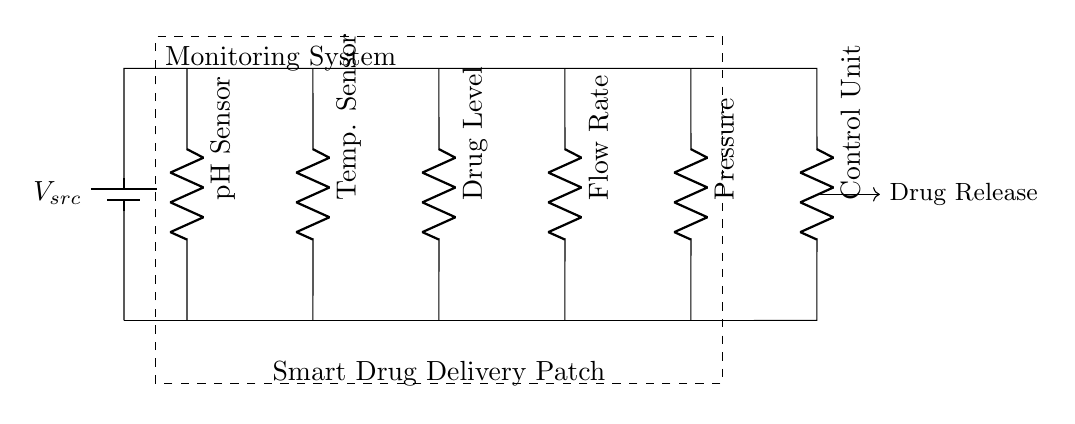What type of sensors are used in the smart drug delivery patch? The circuit diagram indicates five types of sensors: pH Sensor, Temperature Sensor, Drug Level, Flow Rate, and Pressure. These are positioned vertically in parallel, indicating they monitor different parameters simultaneously.
Answer: pH Sensor, Temperature Sensor, Drug Level, Flow Rate, Pressure What is the function of the control unit in this circuit? The control unit is downstream of the sensors and is responsible for processing the data collected from them. It likely regulates the drug release based on this information, which is indicated by the arrow leading to 'Drug Release.'
Answer: Regulate drug release How many resistors are depicted in the circuit? Each sensor is represented as a resistor in the circuit diagram. There are five sensors, therefore there are five resistors present.
Answer: Five What component is connected to all sensors in parallel? The voltage source (V_src) is the power supply which connects to all the sensors, ensuring that each can operate independently while still being powered from the same source.
Answer: Voltage source What does the dashed rectangle represent in the circuit? The dashed rectangle labeled as 'Monitoring System' encompasses all the sensors and indicates that they collectively form a system for monitoring various parameters pertinent to the drug delivery process.
Answer: Monitoring System Which way does the signal for 'Drug Release' flow? The signal for 'Drug Release' flows from the control unit to the output indicated by the arrow, suggesting that it triggers the release of the drug based on the processed data.
Answer: Rightward (from control unit) 